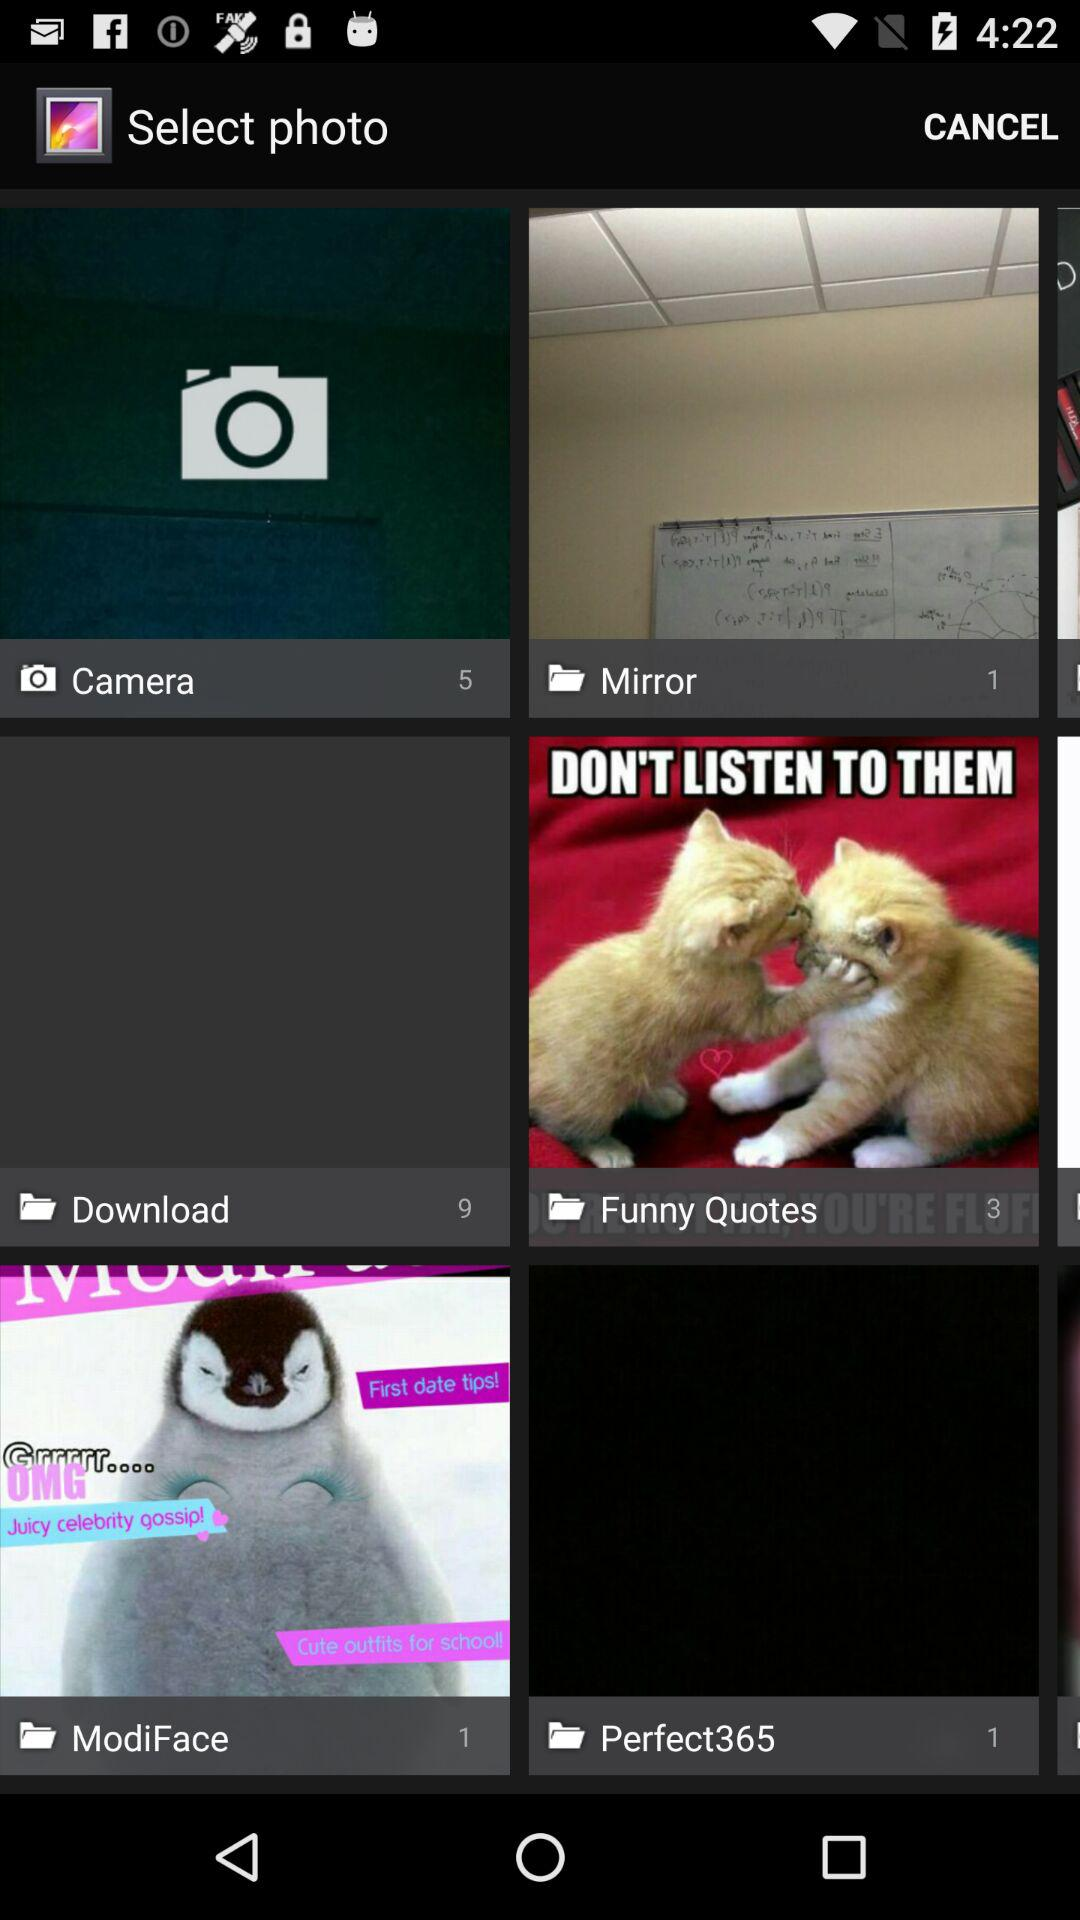What is the number of files in the "Funny Quotes"? There are 3 files in the "Funny Quotes". 